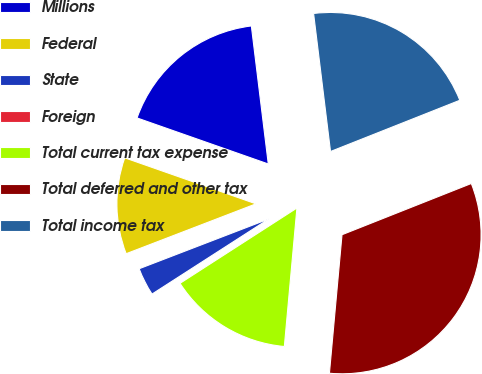Convert chart to OTSL. <chart><loc_0><loc_0><loc_500><loc_500><pie_chart><fcel>Millions<fcel>Federal<fcel>State<fcel>Foreign<fcel>Total current tax expense<fcel>Total deferred and other tax<fcel>Total income tax<nl><fcel>17.69%<fcel>11.21%<fcel>3.26%<fcel>0.01%<fcel>14.45%<fcel>32.45%<fcel>20.94%<nl></chart> 